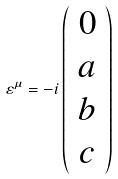Convert formula to latex. <formula><loc_0><loc_0><loc_500><loc_500>\varepsilon ^ { \mu } = - i \left ( \begin{array} { c } 0 \\ a \\ b \\ c \end{array} \right )</formula> 